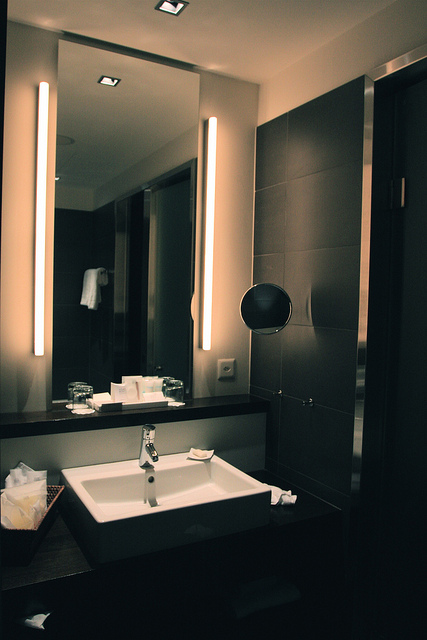If this bathroom could tell a story, what might it say? The bathroom might tell a story of daily rituals and moments of solitude. It's a sanctuary where every day begins and ends, a place for reflection and refreshment. The sleek design elements hint at a thoughtful and curated environment, perhaps crafted with love and care. It might recount the quiet mornings as the household starts to stir, the evenings as the day's stress is washed away, and the many small but significant moments that unfold within its walls. 